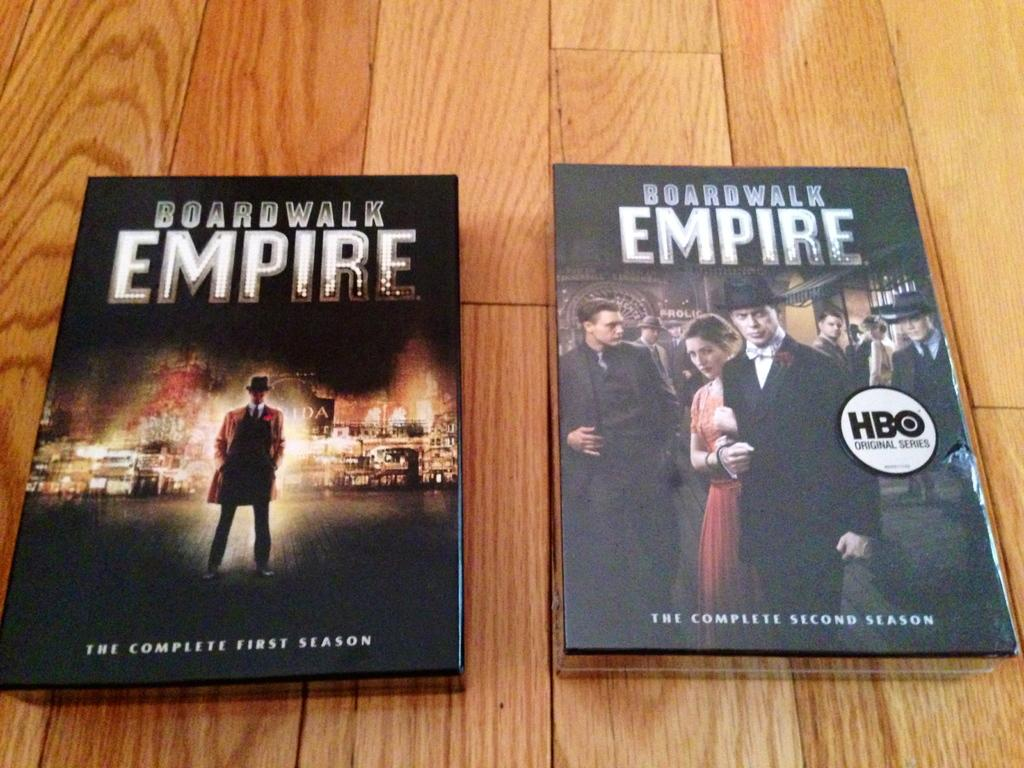<image>
Render a clear and concise summary of the photo. The complete first and second season packages of Boardwalk Empire sits in a wood background. 